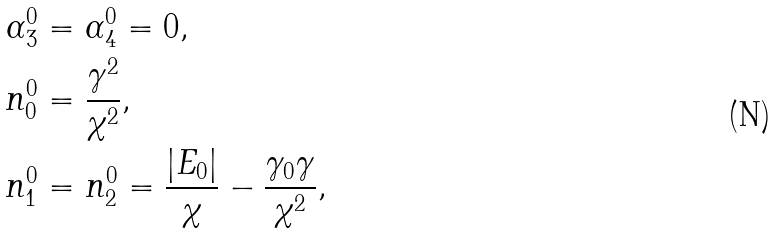<formula> <loc_0><loc_0><loc_500><loc_500>\alpha _ { 3 } ^ { 0 } & = \alpha _ { 4 } ^ { 0 } = 0 , \\ n _ { 0 } ^ { 0 } & = \frac { \gamma ^ { 2 } } { \chi ^ { 2 } } , \\ n _ { 1 } ^ { 0 } & = n _ { 2 } ^ { 0 } = \frac { \left | E _ { 0 } \right | } { \chi } - \frac { \gamma _ { 0 } \gamma } { \chi ^ { 2 } } ,</formula> 